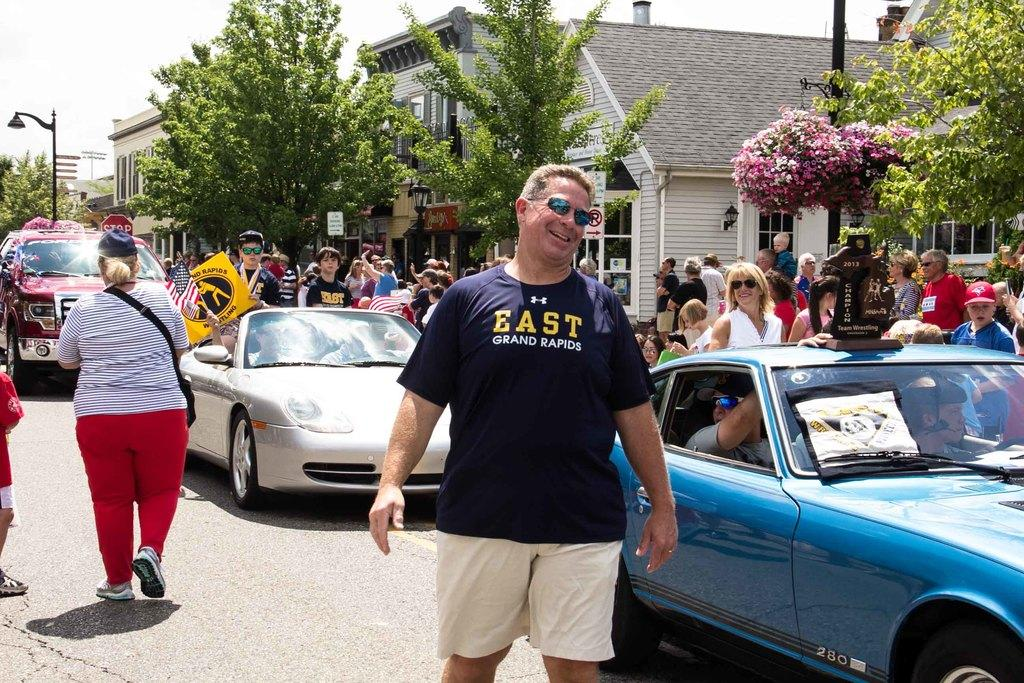What can be seen in the background of the image? There are several guys in the background of the image. What type of vehicles are present in the image? There are modern cars in the image. What color are the rabbits' eyes in the image? There are no rabbits present in the image, so their eyes cannot be described. 